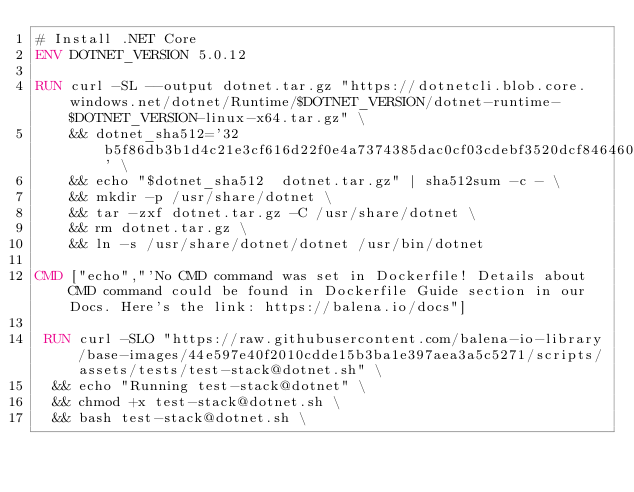Convert code to text. <code><loc_0><loc_0><loc_500><loc_500><_Dockerfile_># Install .NET Core
ENV DOTNET_VERSION 5.0.12

RUN curl -SL --output dotnet.tar.gz "https://dotnetcli.blob.core.windows.net/dotnet/Runtime/$DOTNET_VERSION/dotnet-runtime-$DOTNET_VERSION-linux-x64.tar.gz" \
    && dotnet_sha512='32b5f86db3b1d4c21e3cf616d22f0e4a7374385dac0cf03cdebf3520dcf846460d9677ec1829a180920740a0237d64f6eaa2421d036a67f4fe9fb15d4f6b1db9' \
    && echo "$dotnet_sha512  dotnet.tar.gz" | sha512sum -c - \
    && mkdir -p /usr/share/dotnet \
    && tar -zxf dotnet.tar.gz -C /usr/share/dotnet \
    && rm dotnet.tar.gz \
    && ln -s /usr/share/dotnet/dotnet /usr/bin/dotnet

CMD ["echo","'No CMD command was set in Dockerfile! Details about CMD command could be found in Dockerfile Guide section in our Docs. Here's the link: https://balena.io/docs"]

 RUN curl -SLO "https://raw.githubusercontent.com/balena-io-library/base-images/44e597e40f2010cdde15b3ba1e397aea3a5c5271/scripts/assets/tests/test-stack@dotnet.sh" \
  && echo "Running test-stack@dotnet" \
  && chmod +x test-stack@dotnet.sh \
  && bash test-stack@dotnet.sh \</code> 